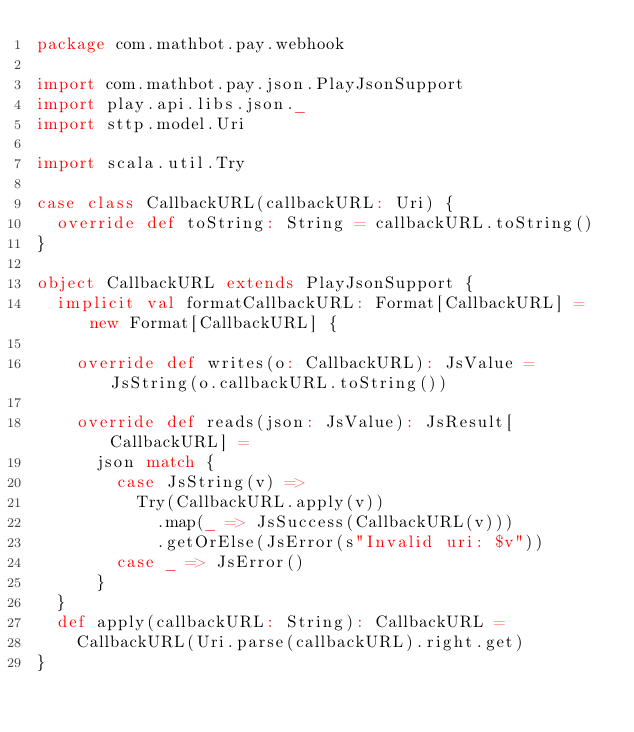<code> <loc_0><loc_0><loc_500><loc_500><_Scala_>package com.mathbot.pay.webhook

import com.mathbot.pay.json.PlayJsonSupport
import play.api.libs.json._
import sttp.model.Uri

import scala.util.Try

case class CallbackURL(callbackURL: Uri) {
  override def toString: String = callbackURL.toString()
}

object CallbackURL extends PlayJsonSupport {
  implicit val formatCallbackURL: Format[CallbackURL] = new Format[CallbackURL] {

    override def writes(o: CallbackURL): JsValue = JsString(o.callbackURL.toString())

    override def reads(json: JsValue): JsResult[CallbackURL] =
      json match {
        case JsString(v) =>
          Try(CallbackURL.apply(v))
            .map(_ => JsSuccess(CallbackURL(v)))
            .getOrElse(JsError(s"Invalid uri: $v"))
        case _ => JsError()
      }
  }
  def apply(callbackURL: String): CallbackURL =
    CallbackURL(Uri.parse(callbackURL).right.get)
}
</code> 